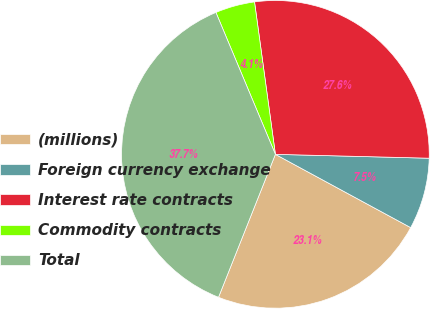Convert chart to OTSL. <chart><loc_0><loc_0><loc_500><loc_500><pie_chart><fcel>(millions)<fcel>Foreign currency exchange<fcel>Interest rate contracts<fcel>Commodity contracts<fcel>Total<nl><fcel>23.13%<fcel>7.5%<fcel>27.57%<fcel>4.15%<fcel>37.66%<nl></chart> 